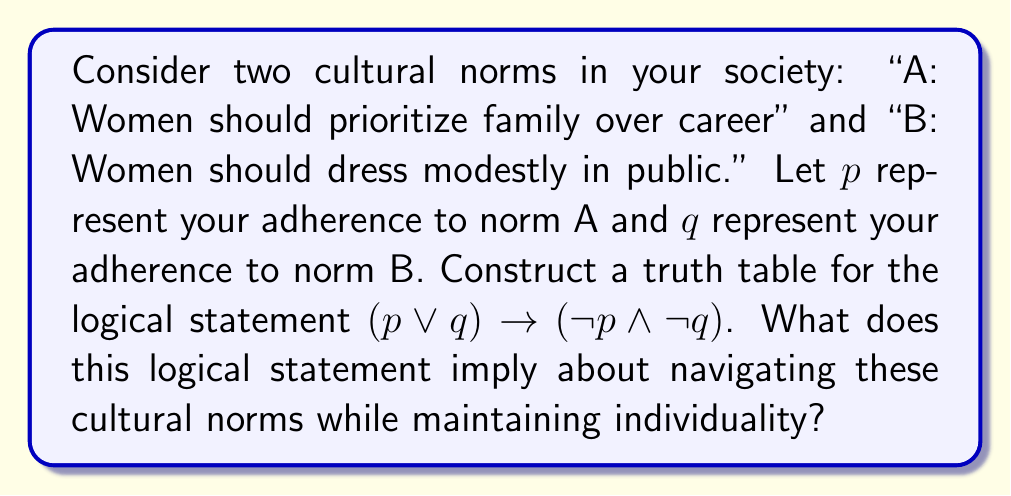Provide a solution to this math problem. To analyze this logical statement, we'll construct a truth table and interpret its results:

1. First, let's create the truth table:

   | p | q | p ∨ q | ¬p | ¬q | ¬p ∧ ¬q | (p ∨ q) → (¬p ∧ ¬q) |
   |---|---|-------|----|----|---------|----------------------|
   | T | T |   T   |  F |  F |    F    |          F           |
   | T | F |   T   |  F |  T |    F    |          F           |
   | F | T |   T   |  T |  F |    F    |          F           |
   | F | F |   F   |  T |  T |    T    |          T           |

2. Let's break down the logical statement:
   - $(p \lor q)$ represents adhering to at least one of the norms
   - $(\neg p \land \neg q)$ represents rejecting both norms
   - The implication $\rightarrow$ suggests that if you adhere to at least one norm, you should reject both

3. Interpreting the truth table:
   - The statement is only true in the last row, where both p and q are false
   - This means the logical statement is only satisfied when you reject both cultural norms

4. Implications for maintaining individuality:
   - The logical structure suggests that adhering to either norm leads to a contradiction with maintaining complete individuality
   - It implies that to fully express your individuality, you may need to reject both norms
   - However, the truth table also shows that there's no logical consistency in partially adhering to norms (rows 2 and 3 are false)

5. Cultural navigation:
   - This logical structure presents a binary view of cultural adherence, which may not reflect the nuanced reality of navigating societal norms
   - It encourages critical thinking about the relationship between cultural norms and individual expression
   - The analysis suggests that maintaining complete individuality might require challenging established norms, but also highlights the complexity of cultural navigation
Answer: The logical statement $(p \lor q) \rightarrow (\neg p \land \neg q)$ is only true when both p and q are false, implying that complete individuality (in the context of these norms) is logically consistent only when rejecting both cultural norms. This binary logical structure encourages critical examination of cultural norms but may oversimplify the nuanced reality of navigating societal expectations while maintaining personal identity. 